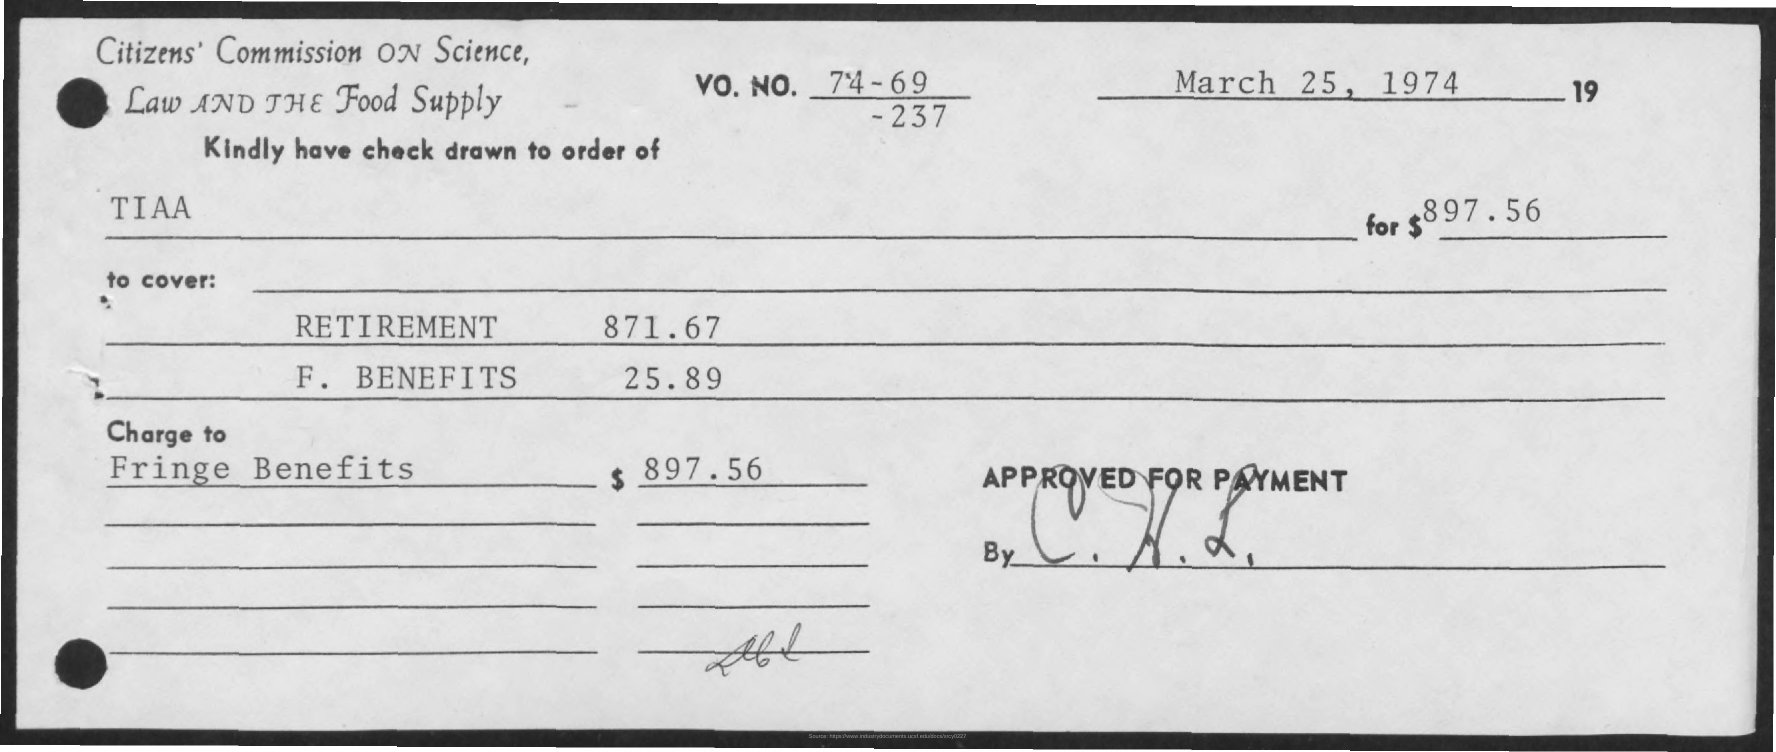Highlight a few significant elements in this photo. The amount given for retirement, as mentioned on the given page, is 871.67... The given check shows an amount of $897.56. The amount given for F.Benefits in the provided page is 25.89. 